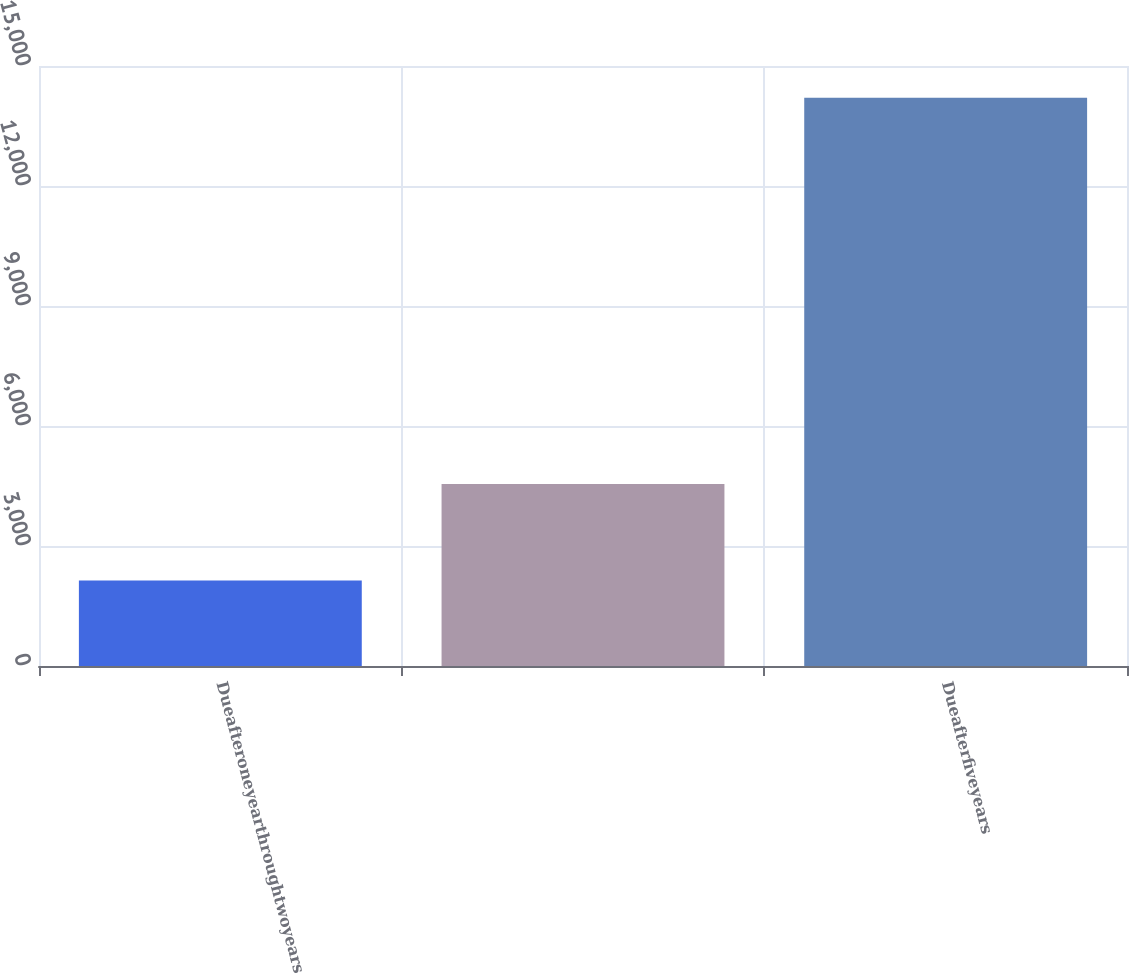Convert chart to OTSL. <chart><loc_0><loc_0><loc_500><loc_500><bar_chart><fcel>Dueafteroneyearthroughtwoyears<fcel>Unnamed: 1<fcel>Dueafterfiveyears<nl><fcel>2138<fcel>4552.2<fcel>14209<nl></chart> 